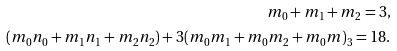Convert formula to latex. <formula><loc_0><loc_0><loc_500><loc_500>m _ { 0 } + m _ { 1 } + m _ { 2 } = 3 , \\ ( m _ { 0 } n _ { 0 } + m _ { 1 } n _ { 1 } + m _ { 2 } n _ { 2 } ) + 3 ( m _ { 0 } m _ { 1 } + m _ { 0 } m _ { 2 } + m _ { 0 } m ) _ { 3 } = 1 8 .</formula> 